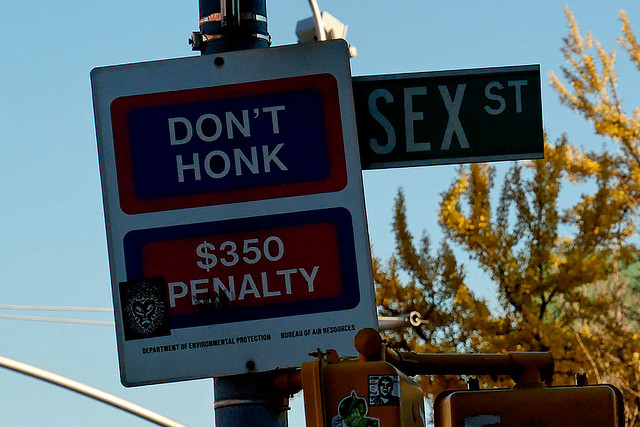Read and extract the text from this image. DON'T HONK SEX ST $350 PENALTY DEPARTMENT ENVIRONMENTAL BUREAU 